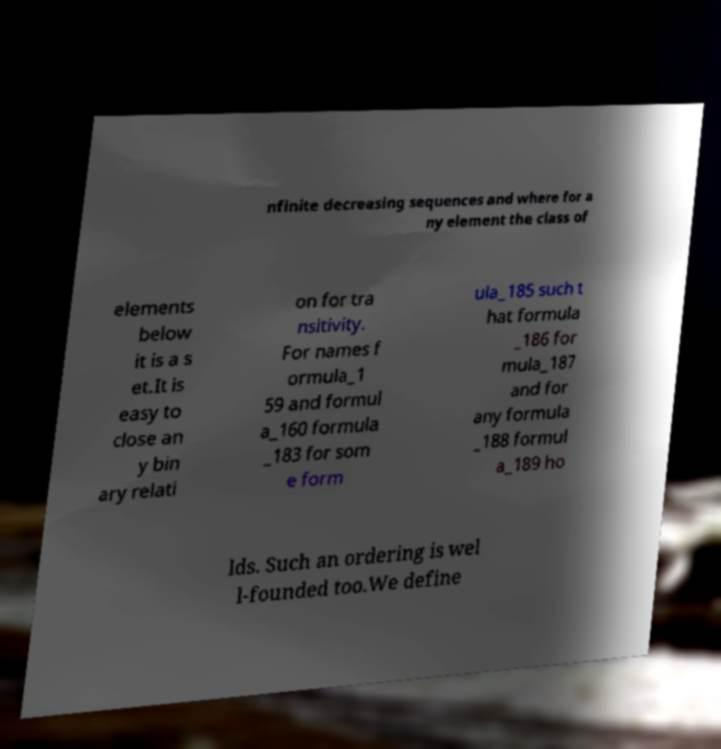I need the written content from this picture converted into text. Can you do that? nfinite decreasing sequences and where for a ny element the class of elements below it is a s et.It is easy to close an y bin ary relati on for tra nsitivity. For names f ormula_1 59 and formul a_160 formula _183 for som e form ula_185 such t hat formula _186 for mula_187 and for any formula _188 formul a_189 ho lds. Such an ordering is wel l-founded too.We define 